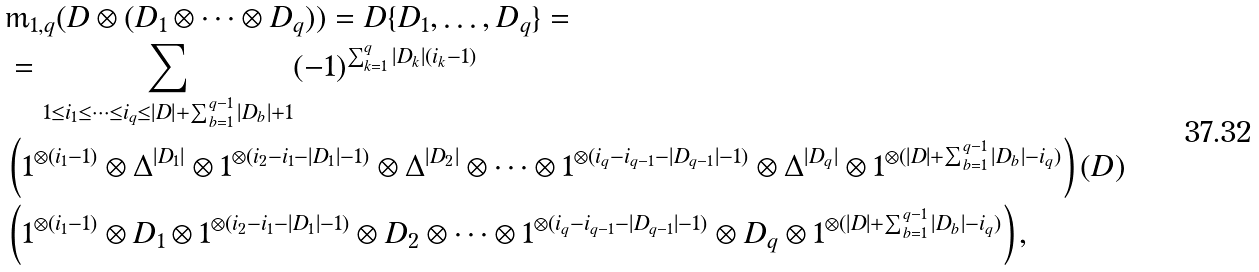<formula> <loc_0><loc_0><loc_500><loc_500>& \mathrm m _ { 1 , q } ( D \otimes ( D _ { 1 } \otimes \cdots \otimes D _ { q } ) ) = D \{ D _ { 1 } , \dots , D _ { q } \} = \\ & = \sum _ { 1 \leq i _ { 1 } \leq \cdots \leq i _ { q } \leq | D | + \sum _ { b = 1 } ^ { q - 1 } | D _ { b } | + 1 } ( - 1 ) ^ { \sum _ { k = 1 } ^ { q } | D _ { k } | \left ( i _ { k } - 1 \right ) } \\ & \left ( 1 ^ { \otimes ( i _ { 1 } - 1 ) } \otimes \Delta ^ { | D _ { 1 } | } \otimes 1 ^ { \otimes ( i _ { 2 } - i _ { 1 } - | D _ { 1 } | - 1 ) } \otimes \Delta ^ { | D _ { 2 } | } \otimes \cdots \otimes 1 ^ { \otimes ( i _ { q } - i _ { q - 1 } - | D _ { q - 1 } | - 1 ) } \otimes \Delta ^ { | D _ { q } | } \otimes 1 ^ { \otimes ( | D | + \sum _ { b = 1 } ^ { q - 1 } | D _ { b } | - i _ { q } ) } \right ) ( D ) \\ & \left ( 1 ^ { \otimes ( i _ { 1 } - 1 ) } \otimes D _ { 1 } \otimes 1 ^ { \otimes ( i _ { 2 } - i _ { 1 } - | D _ { 1 } | - 1 ) } \otimes D _ { 2 } \otimes \cdots \otimes 1 ^ { \otimes ( i _ { q } - i _ { q - 1 } - | D _ { q - 1 } | - 1 ) } \otimes D _ { q } \otimes 1 ^ { \otimes ( | D | + \sum _ { b = 1 } ^ { q - 1 } | D _ { b } | - i _ { q } ) } \right ) ,</formula> 